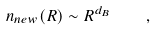<formula> <loc_0><loc_0><loc_500><loc_500>n _ { n e w } ( R ) \sim R ^ { d _ { B } } \quad ,</formula> 